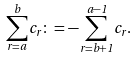Convert formula to latex. <formula><loc_0><loc_0><loc_500><loc_500>\sum _ { r = a } ^ { b } c _ { r } \colon = - \sum _ { r = b + 1 } ^ { a - 1 } c _ { r } .</formula> 